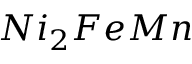Convert formula to latex. <formula><loc_0><loc_0><loc_500><loc_500>N i _ { 2 } F e M n</formula> 